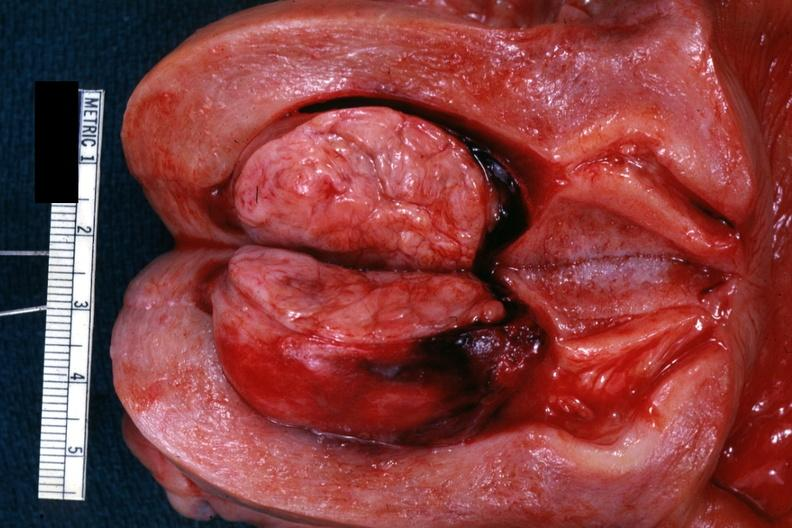what is present?
Answer the question using a single word or phrase. Uterus 